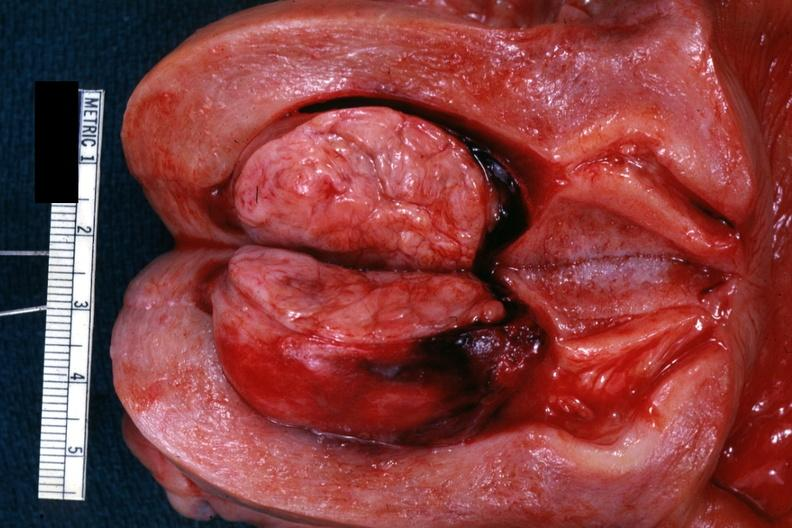what is present?
Answer the question using a single word or phrase. Uterus 